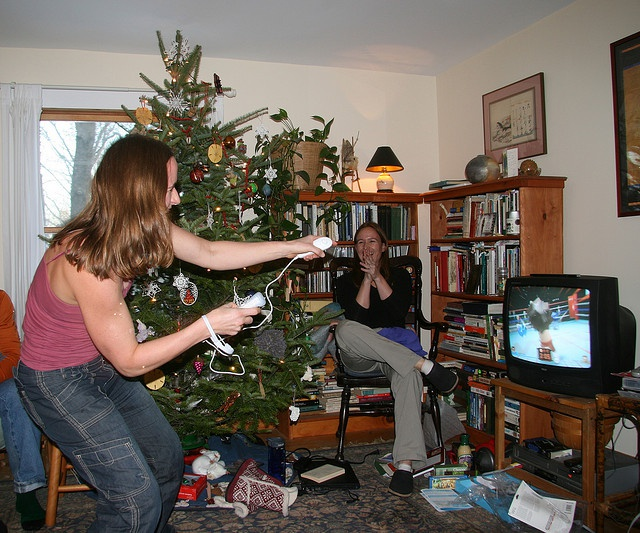Describe the objects in this image and their specific colors. I can see book in gray, black, maroon, and darkgray tones, people in gray, black, brown, and tan tones, tv in gray, black, and lightblue tones, people in gray, black, and navy tones, and potted plant in gray, black, maroon, and darkgray tones in this image. 